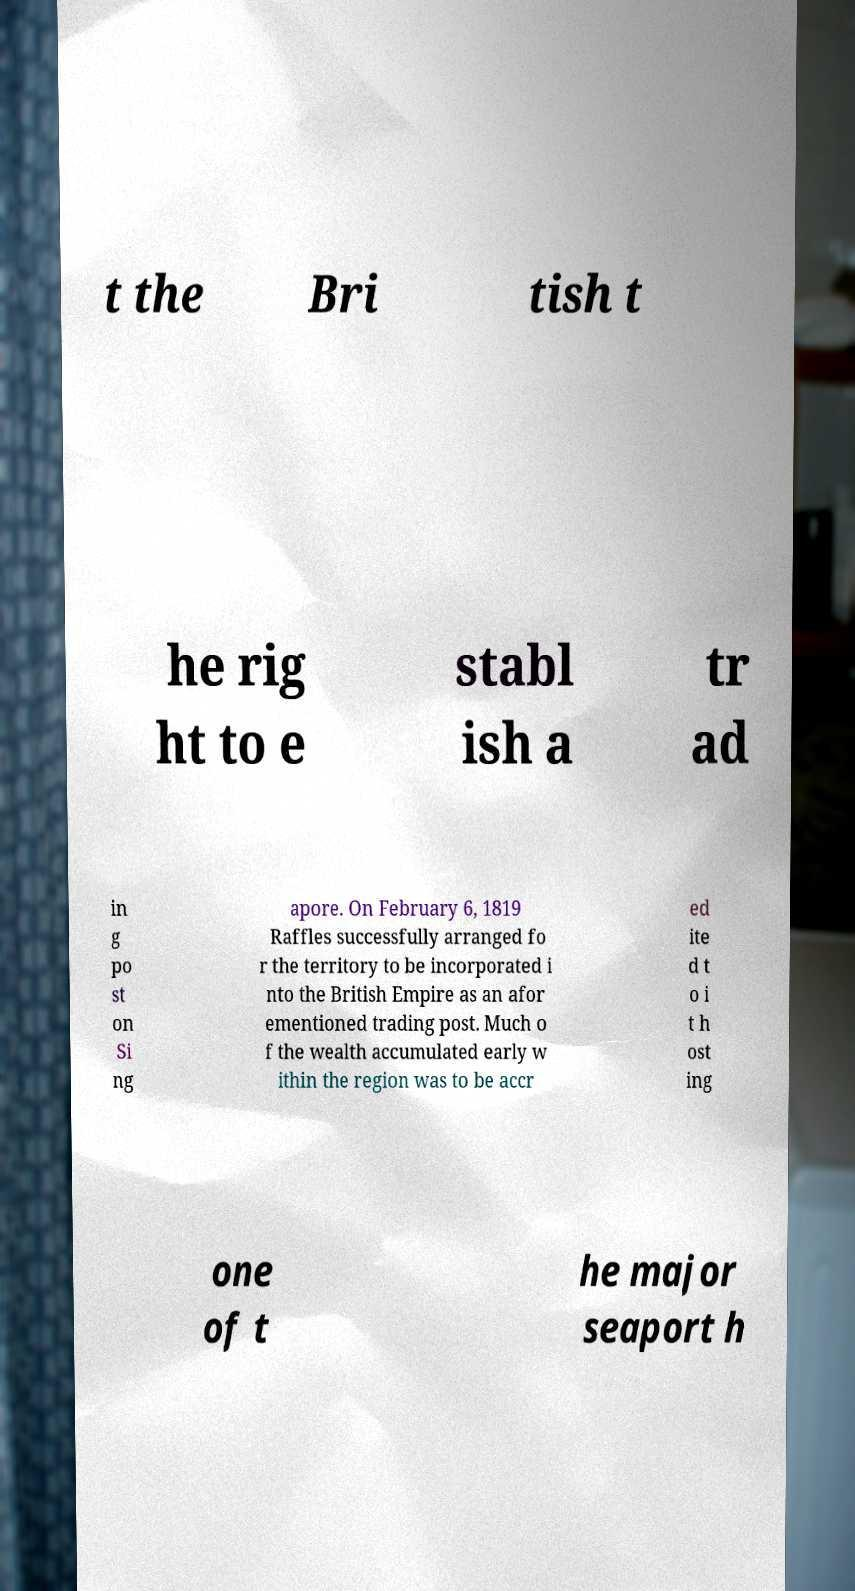For documentation purposes, I need the text within this image transcribed. Could you provide that? t the Bri tish t he rig ht to e stabl ish a tr ad in g po st on Si ng apore. On February 6, 1819 Raffles successfully arranged fo r the territory to be incorporated i nto the British Empire as an afor ementioned trading post. Much o f the wealth accumulated early w ithin the region was to be accr ed ite d t o i t h ost ing one of t he major seaport h 